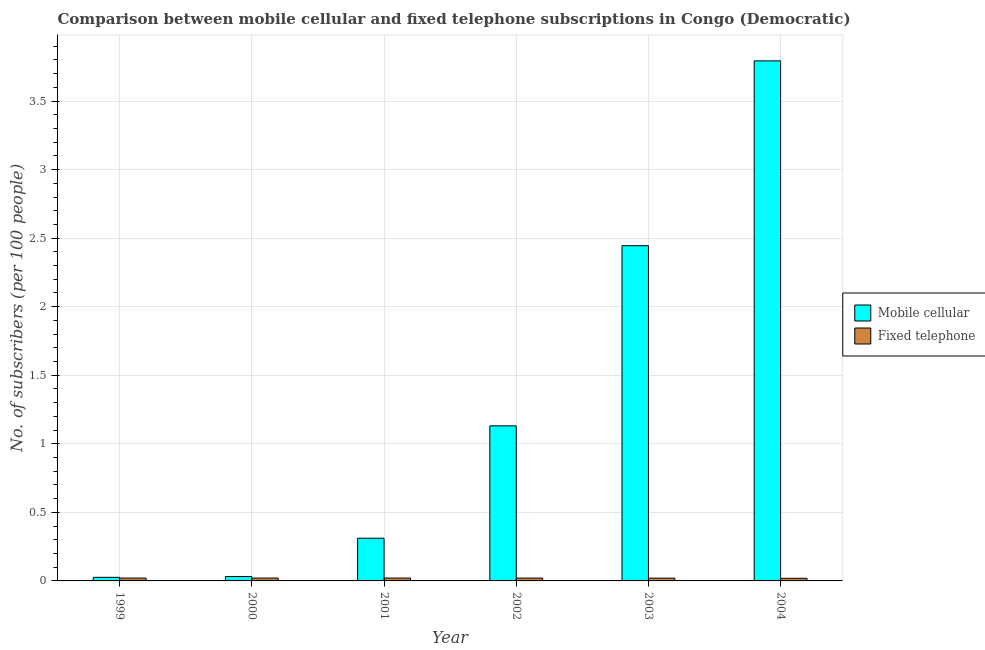How many different coloured bars are there?
Your answer should be compact. 2. How many groups of bars are there?
Make the answer very short. 6. Are the number of bars on each tick of the X-axis equal?
Your answer should be compact. Yes. How many bars are there on the 5th tick from the right?
Offer a very short reply. 2. In how many cases, is the number of bars for a given year not equal to the number of legend labels?
Ensure brevity in your answer.  0. What is the number of fixed telephone subscribers in 1999?
Offer a very short reply. 0.02. Across all years, what is the maximum number of mobile cellular subscribers?
Provide a short and direct response. 3.79. Across all years, what is the minimum number of fixed telephone subscribers?
Keep it short and to the point. 0.02. In which year was the number of fixed telephone subscribers maximum?
Provide a short and direct response. 2001. What is the total number of mobile cellular subscribers in the graph?
Your response must be concise. 7.74. What is the difference between the number of mobile cellular subscribers in 1999 and that in 2004?
Your answer should be compact. -3.77. What is the difference between the number of mobile cellular subscribers in 2003 and the number of fixed telephone subscribers in 2002?
Your answer should be very brief. 1.31. What is the average number of mobile cellular subscribers per year?
Ensure brevity in your answer.  1.29. In how many years, is the number of mobile cellular subscribers greater than 0.5?
Offer a terse response. 3. What is the ratio of the number of mobile cellular subscribers in 2002 to that in 2003?
Keep it short and to the point. 0.46. Is the number of mobile cellular subscribers in 2001 less than that in 2004?
Your answer should be compact. Yes. Is the difference between the number of fixed telephone subscribers in 1999 and 2001 greater than the difference between the number of mobile cellular subscribers in 1999 and 2001?
Your answer should be very brief. No. What is the difference between the highest and the second highest number of mobile cellular subscribers?
Ensure brevity in your answer.  1.35. What is the difference between the highest and the lowest number of fixed telephone subscribers?
Your answer should be very brief. 0. What does the 2nd bar from the left in 2002 represents?
Keep it short and to the point. Fixed telephone. What does the 2nd bar from the right in 2001 represents?
Your answer should be compact. Mobile cellular. How many bars are there?
Your answer should be very brief. 12. Are all the bars in the graph horizontal?
Your answer should be very brief. No. How many years are there in the graph?
Give a very brief answer. 6. Are the values on the major ticks of Y-axis written in scientific E-notation?
Give a very brief answer. No. Does the graph contain any zero values?
Offer a terse response. No. Does the graph contain grids?
Your answer should be very brief. Yes. What is the title of the graph?
Ensure brevity in your answer.  Comparison between mobile cellular and fixed telephone subscriptions in Congo (Democratic). Does "Public credit registry" appear as one of the legend labels in the graph?
Offer a terse response. No. What is the label or title of the X-axis?
Ensure brevity in your answer.  Year. What is the label or title of the Y-axis?
Your answer should be very brief. No. of subscribers (per 100 people). What is the No. of subscribers (per 100 people) of Mobile cellular in 1999?
Provide a short and direct response. 0.03. What is the No. of subscribers (per 100 people) of Fixed telephone in 1999?
Provide a short and direct response. 0.02. What is the No. of subscribers (per 100 people) in Mobile cellular in 2000?
Provide a short and direct response. 0.03. What is the No. of subscribers (per 100 people) in Fixed telephone in 2000?
Give a very brief answer. 0.02. What is the No. of subscribers (per 100 people) in Mobile cellular in 2001?
Your response must be concise. 0.31. What is the No. of subscribers (per 100 people) of Fixed telephone in 2001?
Make the answer very short. 0.02. What is the No. of subscribers (per 100 people) in Mobile cellular in 2002?
Your answer should be compact. 1.13. What is the No. of subscribers (per 100 people) of Fixed telephone in 2002?
Your response must be concise. 0.02. What is the No. of subscribers (per 100 people) of Mobile cellular in 2003?
Make the answer very short. 2.44. What is the No. of subscribers (per 100 people) of Fixed telephone in 2003?
Your answer should be compact. 0.02. What is the No. of subscribers (per 100 people) in Mobile cellular in 2004?
Make the answer very short. 3.79. What is the No. of subscribers (per 100 people) of Fixed telephone in 2004?
Make the answer very short. 0.02. Across all years, what is the maximum No. of subscribers (per 100 people) in Mobile cellular?
Ensure brevity in your answer.  3.79. Across all years, what is the maximum No. of subscribers (per 100 people) in Fixed telephone?
Provide a short and direct response. 0.02. Across all years, what is the minimum No. of subscribers (per 100 people) of Mobile cellular?
Provide a succinct answer. 0.03. Across all years, what is the minimum No. of subscribers (per 100 people) in Fixed telephone?
Your answer should be compact. 0.02. What is the total No. of subscribers (per 100 people) of Mobile cellular in the graph?
Provide a succinct answer. 7.74. What is the total No. of subscribers (per 100 people) in Fixed telephone in the graph?
Ensure brevity in your answer.  0.12. What is the difference between the No. of subscribers (per 100 people) of Mobile cellular in 1999 and that in 2000?
Provide a succinct answer. -0.01. What is the difference between the No. of subscribers (per 100 people) of Fixed telephone in 1999 and that in 2000?
Offer a very short reply. -0. What is the difference between the No. of subscribers (per 100 people) of Mobile cellular in 1999 and that in 2001?
Offer a very short reply. -0.29. What is the difference between the No. of subscribers (per 100 people) in Fixed telephone in 1999 and that in 2001?
Offer a very short reply. -0. What is the difference between the No. of subscribers (per 100 people) in Mobile cellular in 1999 and that in 2002?
Provide a short and direct response. -1.1. What is the difference between the No. of subscribers (per 100 people) of Mobile cellular in 1999 and that in 2003?
Your response must be concise. -2.42. What is the difference between the No. of subscribers (per 100 people) of Fixed telephone in 1999 and that in 2003?
Provide a short and direct response. 0. What is the difference between the No. of subscribers (per 100 people) of Mobile cellular in 1999 and that in 2004?
Offer a very short reply. -3.77. What is the difference between the No. of subscribers (per 100 people) of Fixed telephone in 1999 and that in 2004?
Keep it short and to the point. 0. What is the difference between the No. of subscribers (per 100 people) in Mobile cellular in 2000 and that in 2001?
Give a very brief answer. -0.28. What is the difference between the No. of subscribers (per 100 people) of Fixed telephone in 2000 and that in 2001?
Provide a short and direct response. -0. What is the difference between the No. of subscribers (per 100 people) of Mobile cellular in 2000 and that in 2002?
Provide a succinct answer. -1.1. What is the difference between the No. of subscribers (per 100 people) in Fixed telephone in 2000 and that in 2002?
Offer a terse response. 0. What is the difference between the No. of subscribers (per 100 people) of Mobile cellular in 2000 and that in 2003?
Your answer should be very brief. -2.41. What is the difference between the No. of subscribers (per 100 people) of Fixed telephone in 2000 and that in 2003?
Provide a succinct answer. 0. What is the difference between the No. of subscribers (per 100 people) in Mobile cellular in 2000 and that in 2004?
Your answer should be compact. -3.76. What is the difference between the No. of subscribers (per 100 people) of Fixed telephone in 2000 and that in 2004?
Make the answer very short. 0. What is the difference between the No. of subscribers (per 100 people) of Mobile cellular in 2001 and that in 2002?
Offer a very short reply. -0.82. What is the difference between the No. of subscribers (per 100 people) in Fixed telephone in 2001 and that in 2002?
Keep it short and to the point. 0. What is the difference between the No. of subscribers (per 100 people) of Mobile cellular in 2001 and that in 2003?
Give a very brief answer. -2.13. What is the difference between the No. of subscribers (per 100 people) in Fixed telephone in 2001 and that in 2003?
Your response must be concise. 0. What is the difference between the No. of subscribers (per 100 people) of Mobile cellular in 2001 and that in 2004?
Provide a short and direct response. -3.48. What is the difference between the No. of subscribers (per 100 people) in Fixed telephone in 2001 and that in 2004?
Offer a very short reply. 0. What is the difference between the No. of subscribers (per 100 people) of Mobile cellular in 2002 and that in 2003?
Provide a short and direct response. -1.31. What is the difference between the No. of subscribers (per 100 people) in Mobile cellular in 2002 and that in 2004?
Make the answer very short. -2.66. What is the difference between the No. of subscribers (per 100 people) in Fixed telephone in 2002 and that in 2004?
Give a very brief answer. 0. What is the difference between the No. of subscribers (per 100 people) in Mobile cellular in 2003 and that in 2004?
Your answer should be very brief. -1.35. What is the difference between the No. of subscribers (per 100 people) of Fixed telephone in 2003 and that in 2004?
Ensure brevity in your answer.  0. What is the difference between the No. of subscribers (per 100 people) in Mobile cellular in 1999 and the No. of subscribers (per 100 people) in Fixed telephone in 2000?
Provide a succinct answer. 0.01. What is the difference between the No. of subscribers (per 100 people) in Mobile cellular in 1999 and the No. of subscribers (per 100 people) in Fixed telephone in 2001?
Your answer should be very brief. 0.01. What is the difference between the No. of subscribers (per 100 people) of Mobile cellular in 1999 and the No. of subscribers (per 100 people) of Fixed telephone in 2002?
Ensure brevity in your answer.  0.01. What is the difference between the No. of subscribers (per 100 people) in Mobile cellular in 1999 and the No. of subscribers (per 100 people) in Fixed telephone in 2003?
Provide a succinct answer. 0.01. What is the difference between the No. of subscribers (per 100 people) in Mobile cellular in 1999 and the No. of subscribers (per 100 people) in Fixed telephone in 2004?
Make the answer very short. 0.01. What is the difference between the No. of subscribers (per 100 people) of Mobile cellular in 2000 and the No. of subscribers (per 100 people) of Fixed telephone in 2001?
Your answer should be very brief. 0.01. What is the difference between the No. of subscribers (per 100 people) in Mobile cellular in 2000 and the No. of subscribers (per 100 people) in Fixed telephone in 2002?
Provide a short and direct response. 0.01. What is the difference between the No. of subscribers (per 100 people) of Mobile cellular in 2000 and the No. of subscribers (per 100 people) of Fixed telephone in 2003?
Provide a succinct answer. 0.01. What is the difference between the No. of subscribers (per 100 people) of Mobile cellular in 2000 and the No. of subscribers (per 100 people) of Fixed telephone in 2004?
Make the answer very short. 0.01. What is the difference between the No. of subscribers (per 100 people) of Mobile cellular in 2001 and the No. of subscribers (per 100 people) of Fixed telephone in 2002?
Provide a succinct answer. 0.29. What is the difference between the No. of subscribers (per 100 people) of Mobile cellular in 2001 and the No. of subscribers (per 100 people) of Fixed telephone in 2003?
Provide a short and direct response. 0.29. What is the difference between the No. of subscribers (per 100 people) in Mobile cellular in 2001 and the No. of subscribers (per 100 people) in Fixed telephone in 2004?
Ensure brevity in your answer.  0.29. What is the difference between the No. of subscribers (per 100 people) of Mobile cellular in 2002 and the No. of subscribers (per 100 people) of Fixed telephone in 2003?
Your answer should be compact. 1.11. What is the difference between the No. of subscribers (per 100 people) in Mobile cellular in 2002 and the No. of subscribers (per 100 people) in Fixed telephone in 2004?
Ensure brevity in your answer.  1.11. What is the difference between the No. of subscribers (per 100 people) in Mobile cellular in 2003 and the No. of subscribers (per 100 people) in Fixed telephone in 2004?
Your answer should be compact. 2.43. What is the average No. of subscribers (per 100 people) of Mobile cellular per year?
Ensure brevity in your answer.  1.29. What is the average No. of subscribers (per 100 people) of Fixed telephone per year?
Provide a succinct answer. 0.02. In the year 1999, what is the difference between the No. of subscribers (per 100 people) in Mobile cellular and No. of subscribers (per 100 people) in Fixed telephone?
Provide a short and direct response. 0.01. In the year 2000, what is the difference between the No. of subscribers (per 100 people) in Mobile cellular and No. of subscribers (per 100 people) in Fixed telephone?
Offer a terse response. 0.01. In the year 2001, what is the difference between the No. of subscribers (per 100 people) of Mobile cellular and No. of subscribers (per 100 people) of Fixed telephone?
Offer a terse response. 0.29. In the year 2002, what is the difference between the No. of subscribers (per 100 people) of Mobile cellular and No. of subscribers (per 100 people) of Fixed telephone?
Your response must be concise. 1.11. In the year 2003, what is the difference between the No. of subscribers (per 100 people) in Mobile cellular and No. of subscribers (per 100 people) in Fixed telephone?
Keep it short and to the point. 2.42. In the year 2004, what is the difference between the No. of subscribers (per 100 people) in Mobile cellular and No. of subscribers (per 100 people) in Fixed telephone?
Give a very brief answer. 3.77. What is the ratio of the No. of subscribers (per 100 people) of Mobile cellular in 1999 to that in 2000?
Offer a terse response. 0.82. What is the ratio of the No. of subscribers (per 100 people) in Mobile cellular in 1999 to that in 2001?
Your response must be concise. 0.08. What is the ratio of the No. of subscribers (per 100 people) in Fixed telephone in 1999 to that in 2001?
Make the answer very short. 1. What is the ratio of the No. of subscribers (per 100 people) in Mobile cellular in 1999 to that in 2002?
Provide a short and direct response. 0.02. What is the ratio of the No. of subscribers (per 100 people) in Mobile cellular in 1999 to that in 2003?
Provide a short and direct response. 0.01. What is the ratio of the No. of subscribers (per 100 people) in Fixed telephone in 1999 to that in 2003?
Your response must be concise. 1.03. What is the ratio of the No. of subscribers (per 100 people) in Mobile cellular in 1999 to that in 2004?
Give a very brief answer. 0.01. What is the ratio of the No. of subscribers (per 100 people) of Fixed telephone in 1999 to that in 2004?
Provide a short and direct response. 1.09. What is the ratio of the No. of subscribers (per 100 people) of Mobile cellular in 2000 to that in 2001?
Your answer should be compact. 0.1. What is the ratio of the No. of subscribers (per 100 people) of Fixed telephone in 2000 to that in 2001?
Provide a succinct answer. 1. What is the ratio of the No. of subscribers (per 100 people) in Mobile cellular in 2000 to that in 2002?
Keep it short and to the point. 0.03. What is the ratio of the No. of subscribers (per 100 people) in Mobile cellular in 2000 to that in 2003?
Give a very brief answer. 0.01. What is the ratio of the No. of subscribers (per 100 people) in Fixed telephone in 2000 to that in 2003?
Offer a terse response. 1.03. What is the ratio of the No. of subscribers (per 100 people) of Mobile cellular in 2000 to that in 2004?
Your answer should be very brief. 0.01. What is the ratio of the No. of subscribers (per 100 people) in Fixed telephone in 2000 to that in 2004?
Offer a very short reply. 1.09. What is the ratio of the No. of subscribers (per 100 people) in Mobile cellular in 2001 to that in 2002?
Offer a very short reply. 0.28. What is the ratio of the No. of subscribers (per 100 people) of Fixed telephone in 2001 to that in 2002?
Your answer should be compact. 1.01. What is the ratio of the No. of subscribers (per 100 people) of Mobile cellular in 2001 to that in 2003?
Your answer should be very brief. 0.13. What is the ratio of the No. of subscribers (per 100 people) in Fixed telephone in 2001 to that in 2003?
Offer a terse response. 1.03. What is the ratio of the No. of subscribers (per 100 people) of Mobile cellular in 2001 to that in 2004?
Ensure brevity in your answer.  0.08. What is the ratio of the No. of subscribers (per 100 people) in Fixed telephone in 2001 to that in 2004?
Your response must be concise. 1.09. What is the ratio of the No. of subscribers (per 100 people) in Mobile cellular in 2002 to that in 2003?
Your answer should be very brief. 0.46. What is the ratio of the No. of subscribers (per 100 people) of Fixed telephone in 2002 to that in 2003?
Your answer should be very brief. 1.03. What is the ratio of the No. of subscribers (per 100 people) of Mobile cellular in 2002 to that in 2004?
Ensure brevity in your answer.  0.3. What is the ratio of the No. of subscribers (per 100 people) in Fixed telephone in 2002 to that in 2004?
Offer a very short reply. 1.09. What is the ratio of the No. of subscribers (per 100 people) of Mobile cellular in 2003 to that in 2004?
Give a very brief answer. 0.64. What is the ratio of the No. of subscribers (per 100 people) in Fixed telephone in 2003 to that in 2004?
Give a very brief answer. 1.06. What is the difference between the highest and the second highest No. of subscribers (per 100 people) of Mobile cellular?
Provide a short and direct response. 1.35. What is the difference between the highest and the lowest No. of subscribers (per 100 people) in Mobile cellular?
Your response must be concise. 3.77. What is the difference between the highest and the lowest No. of subscribers (per 100 people) in Fixed telephone?
Your answer should be very brief. 0. 